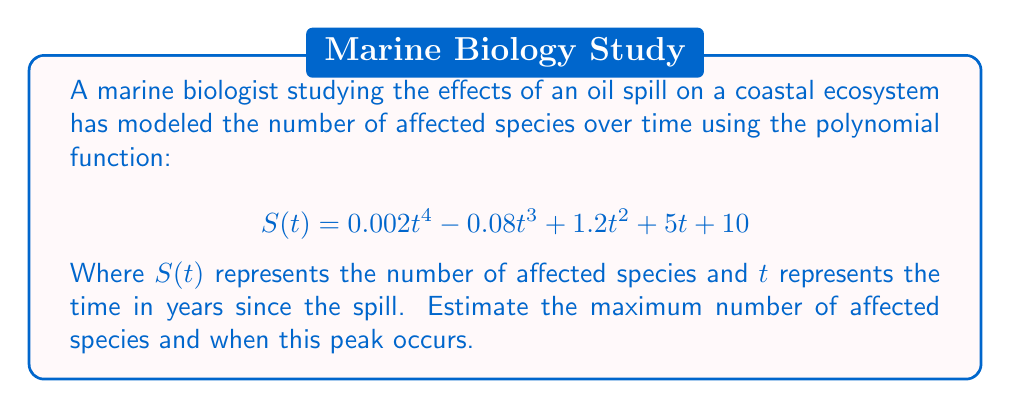Show me your answer to this math problem. To find the maximum number of affected species and when it occurs, we need to follow these steps:

1) Find the derivative of $S(t)$:
   $$S'(t) = 0.008t^3 - 0.24t^2 + 2.4t + 5$$

2) Set the derivative equal to zero to find critical points:
   $$0.008t^3 - 0.24t^2 + 2.4t + 5 = 0$$

3) This cubic equation is difficult to solve by hand. Using a graphing calculator or computer algebra system, we find that the equation has three real roots: approximately -5.77, 5.95, and 20.82.

4) Since time cannot be negative in this context, we can discard the negative root. The root at 20.82 years is beyond the typical recovery period for most ecosystems after an oil spill, so the most relevant critical point is at t ≈ 5.95 years.

5) To confirm this is a maximum, we can check the second derivative:
   $$S''(t) = 0.024t^2 - 0.48t + 2.4$$
   
   Evaluating at t = 5.95:
   $$S''(5.95) ≈ -0.1416 < 0$$

   This confirms that t ≈ 5.95 years corresponds to a local maximum.

6) To find the maximum number of affected species, we evaluate S(5.95):
   $$S(5.95) ≈ 94.7$$

Therefore, the model predicts that the number of affected species will reach a maximum of about 95 species after approximately 6 years.
Answer: Maximum of 95 species at 6 years 